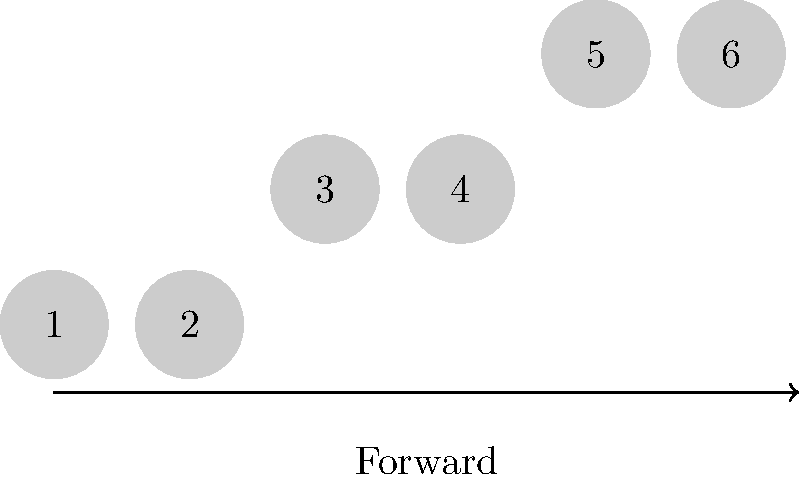In the traditional Valle region dance, what is the correct sequence of steps represented by the footprint diagram? To determine the correct sequence of steps in the traditional Valle region dance, let's analyze the footprint diagram:

1. The diagram shows six footprints, numbered from 1 to 6.
2. The arrow at the bottom indicates the forward direction of movement.
3. We can observe that the steps follow a specific pattern:
   - Steps 1 and 2 are at the same vertical level
   - Steps 3 and 4 are at the same vertical level, but higher than 1 and 2
   - Steps 5 and 6 are at the same vertical level, but higher than 3 and 4
4. This pattern represents a progressive forward and upward movement.
5. In traditional Valle region dances, this pattern is known as the "Escalera" or "Staircase" step.
6. The correct sequence is: two steps forward, two steps diagonally forward and up, two more steps diagonally forward and up.

Therefore, the correct sequence of steps represented by the footprint diagram is the "Escalera" or "Staircase" step pattern of the traditional Valle region dance.
Answer: Escalera (Staircase) step pattern 